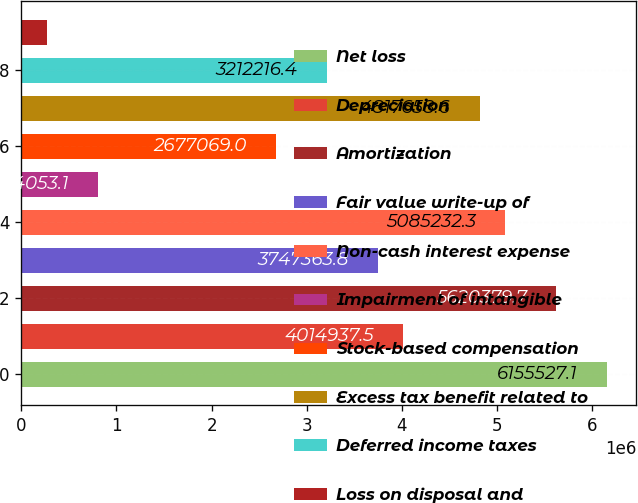Convert chart to OTSL. <chart><loc_0><loc_0><loc_500><loc_500><bar_chart><fcel>Net loss<fcel>Depreciation<fcel>Amortization<fcel>Fair value write-up of<fcel>Non-cash interest expense<fcel>Impairment of intangible<fcel>Stock-based compensation<fcel>Excess tax benefit related to<fcel>Deferred income taxes<fcel>Loss on disposal and<nl><fcel>6.15553e+06<fcel>4.01494e+06<fcel>5.62038e+06<fcel>3.74736e+06<fcel>5.08523e+06<fcel>804053<fcel>2.67707e+06<fcel>4.81766e+06<fcel>3.21222e+06<fcel>268906<nl></chart> 